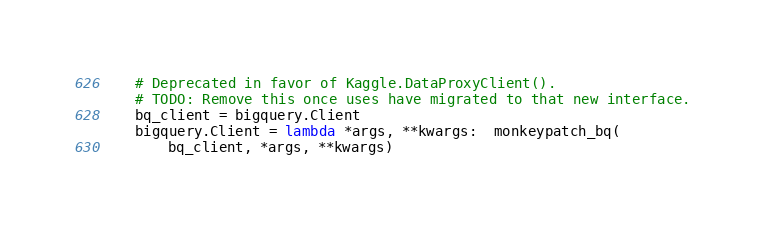<code> <loc_0><loc_0><loc_500><loc_500><_Python_>    # Deprecated in favor of Kaggle.DataProxyClient().
    # TODO: Remove this once uses have migrated to that new interface.
    bq_client = bigquery.Client
    bigquery.Client = lambda *args, **kwargs:  monkeypatch_bq(
        bq_client, *args, **kwargs)
</code> 